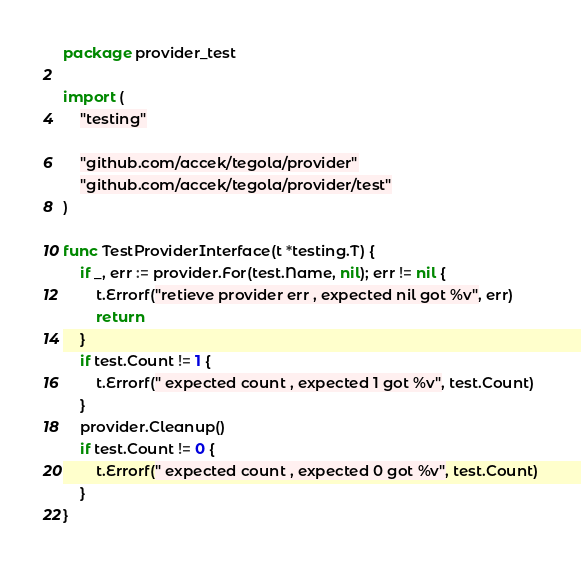<code> <loc_0><loc_0><loc_500><loc_500><_Go_>package provider_test

import (
	"testing"

	"github.com/accek/tegola/provider"
	"github.com/accek/tegola/provider/test"
)

func TestProviderInterface(t *testing.T) {
	if _, err := provider.For(test.Name, nil); err != nil {
		t.Errorf("retieve provider err , expected nil got %v", err)
		return
	}
	if test.Count != 1 {
		t.Errorf(" expected count , expected 1 got %v", test.Count)
	}
	provider.Cleanup()
	if test.Count != 0 {
		t.Errorf(" expected count , expected 0 got %v", test.Count)
	}
}
</code> 